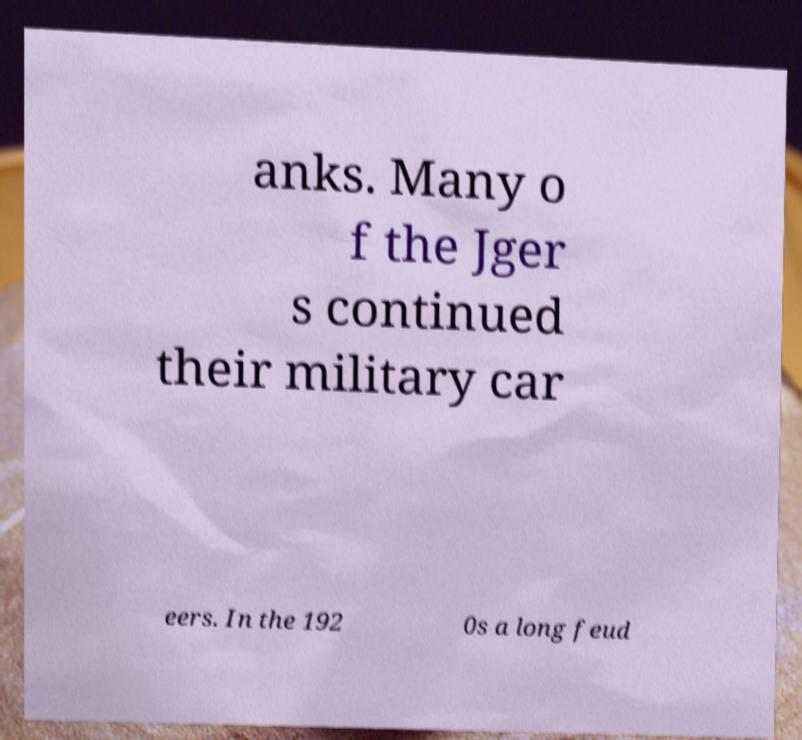I need the written content from this picture converted into text. Can you do that? anks. Many o f the Jger s continued their military car eers. In the 192 0s a long feud 